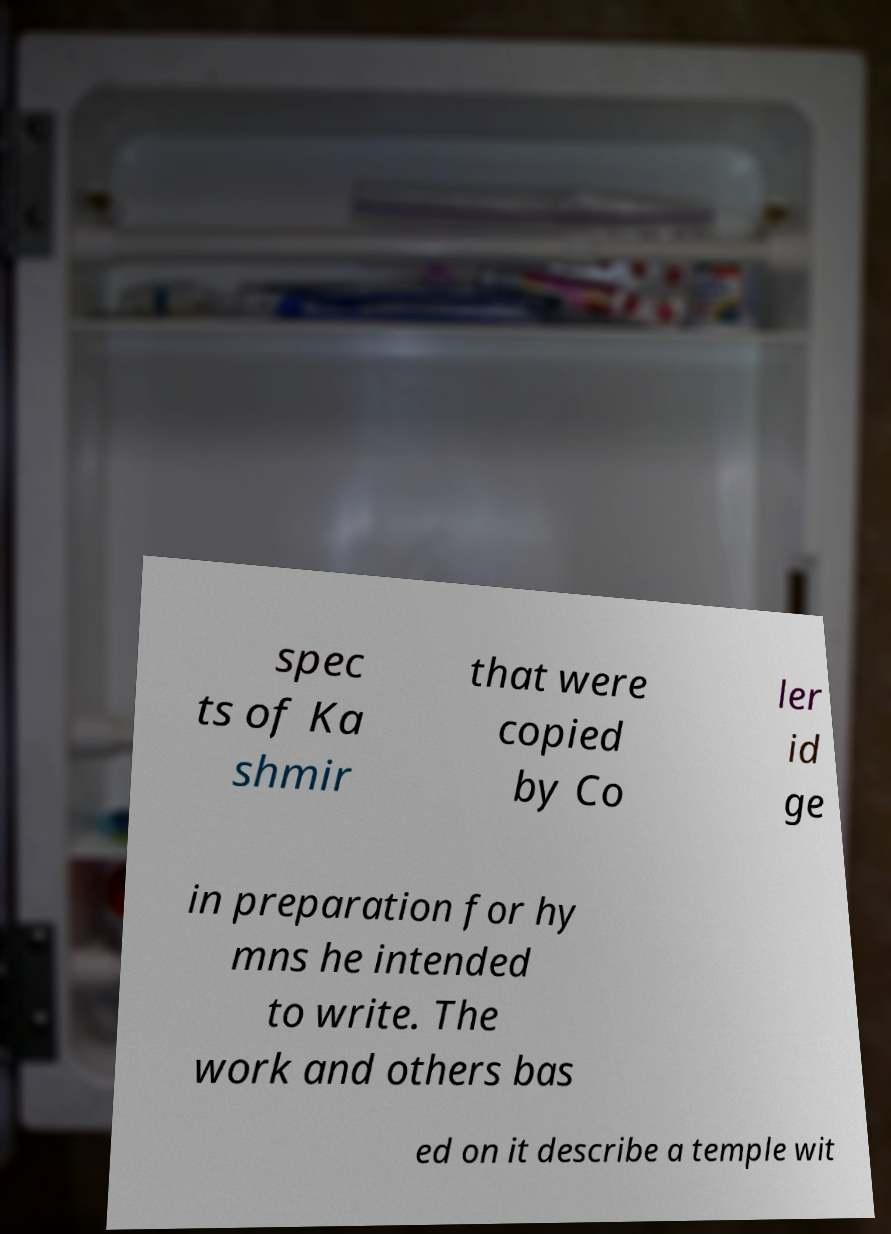Can you read and provide the text displayed in the image?This photo seems to have some interesting text. Can you extract and type it out for me? spec ts of Ka shmir that were copied by Co ler id ge in preparation for hy mns he intended to write. The work and others bas ed on it describe a temple wit 